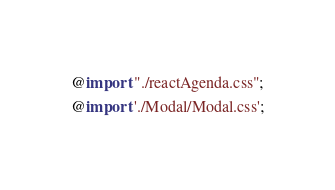Convert code to text. <code><loc_0><loc_0><loc_500><loc_500><_CSS_>@import "./reactAgenda.css";
@import './Modal/Modal.css';
</code> 